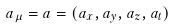<formula> <loc_0><loc_0><loc_500><loc_500>a _ { \mu } = a = ( a _ { x } , a _ { y } , a _ { z } , a _ { t } )</formula> 